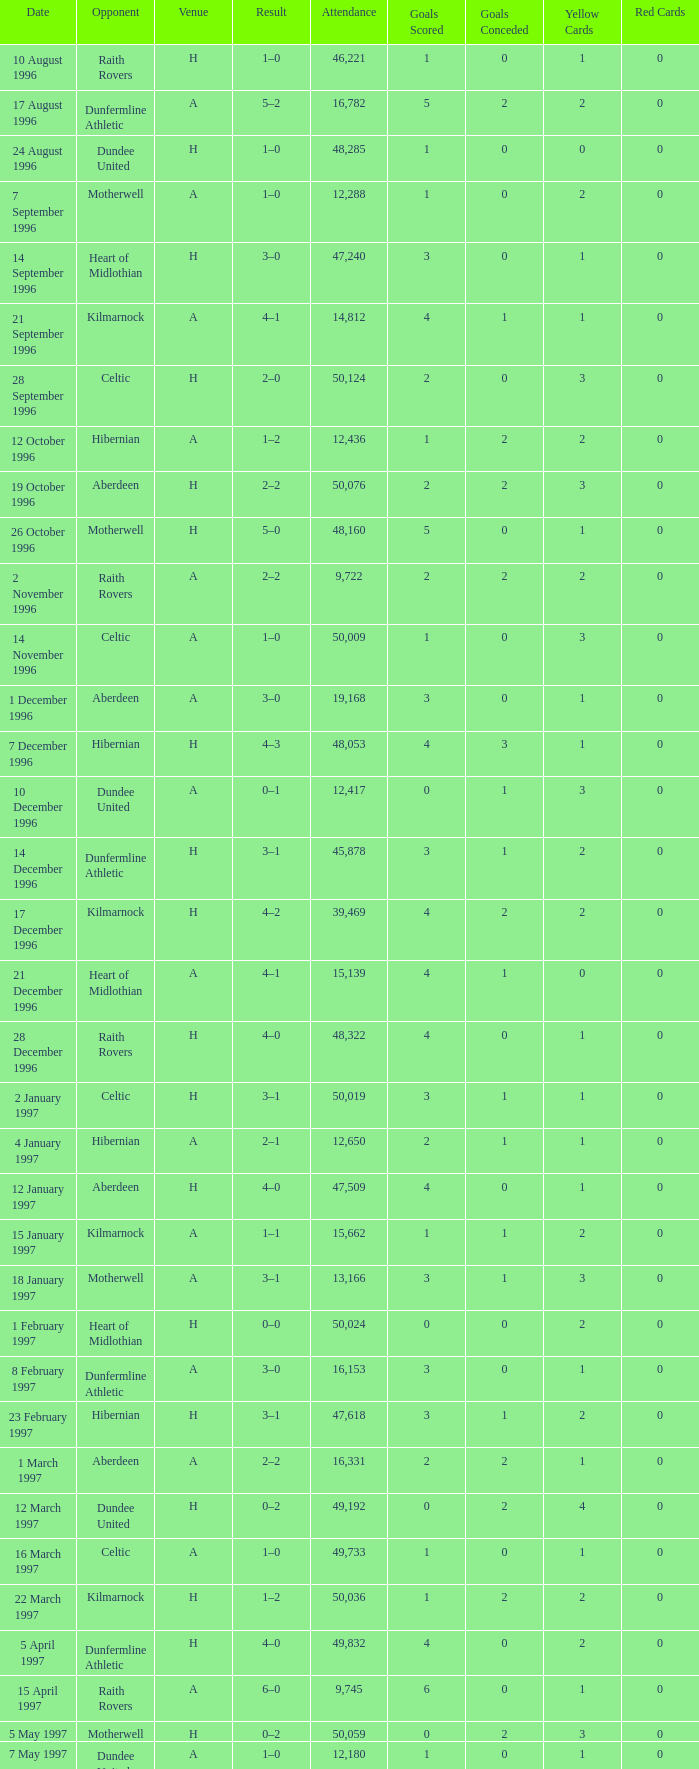Give me the full table as a dictionary. {'header': ['Date', 'Opponent', 'Venue', 'Result', 'Attendance', 'Goals Scored', 'Goals Conceded', 'Yellow Cards', 'Red Cards'], 'rows': [['10 August 1996', 'Raith Rovers', 'H', '1–0', '46,221', '1', '0', '1', '0'], ['17 August 1996', 'Dunfermline Athletic', 'A', '5–2', '16,782', '5', '2', '2', '0'], ['24 August 1996', 'Dundee United', 'H', '1–0', '48,285', '1', '0', '0', '0'], ['7 September 1996', 'Motherwell', 'A', '1–0', '12,288', '1', '0', '2', '0'], ['14 September 1996', 'Heart of Midlothian', 'H', '3–0', '47,240', '3', '0', '1', '0'], ['21 September 1996', 'Kilmarnock', 'A', '4–1', '14,812', '4', '1', '1', '0'], ['28 September 1996', 'Celtic', 'H', '2–0', '50,124', '2', '0', '3', '0'], ['12 October 1996', 'Hibernian', 'A', '1–2', '12,436', '1', '2', '2', '0'], ['19 October 1996', 'Aberdeen', 'H', '2–2', '50,076', '2', '2', '3', '0'], ['26 October 1996', 'Motherwell', 'H', '5–0', '48,160', '5', '0', '1', '0'], ['2 November 1996', 'Raith Rovers', 'A', '2–2', '9,722', '2', '2', '2', '0'], ['14 November 1996', 'Celtic', 'A', '1–0', '50,009', '1', '0', '3', '0'], ['1 December 1996', 'Aberdeen', 'A', '3–0', '19,168', '3', '0', '1', '0'], ['7 December 1996', 'Hibernian', 'H', '4–3', '48,053', '4', '3', '1', '0'], ['10 December 1996', 'Dundee United', 'A', '0–1', '12,417', '0', '1', '3', '0'], ['14 December 1996', 'Dunfermline Athletic', 'H', '3–1', '45,878', '3', '1', '2', '0'], ['17 December 1996', 'Kilmarnock', 'H', '4–2', '39,469', '4', '2', '2', '0'], ['21 December 1996', 'Heart of Midlothian', 'A', '4–1', '15,139', '4', '1', '0', '0'], ['28 December 1996', 'Raith Rovers', 'H', '4–0', '48,322', '4', '0', '1', '0'], ['2 January 1997', 'Celtic', 'H', '3–1', '50,019', '3', '1', '1', '0'], ['4 January 1997', 'Hibernian', 'A', '2–1', '12,650', '2', '1', '1', '0'], ['12 January 1997', 'Aberdeen', 'H', '4–0', '47,509', '4', '0', '1', '0'], ['15 January 1997', 'Kilmarnock', 'A', '1–1', '15,662', '1', '1', '2', '0'], ['18 January 1997', 'Motherwell', 'A', '3–1', '13,166', '3', '1', '3', '0'], ['1 February 1997', 'Heart of Midlothian', 'H', '0–0', '50,024', '0', '0', '2', '0'], ['8 February 1997', 'Dunfermline Athletic', 'A', '3–0', '16,153', '3', '0', '1', '0'], ['23 February 1997', 'Hibernian', 'H', '3–1', '47,618', '3', '1', '2', '0'], ['1 March 1997', 'Aberdeen', 'A', '2–2', '16,331', '2', '2', '1', '0'], ['12 March 1997', 'Dundee United', 'H', '0–2', '49,192', '0', '2', '4', '0'], ['16 March 1997', 'Celtic', 'A', '1–0', '49,733', '1', '0', '1', '0'], ['22 March 1997', 'Kilmarnock', 'H', '1–2', '50,036', '1', '2', '2', '0'], ['5 April 1997', 'Dunfermline Athletic', 'H', '4–0', '49,832', '4', '0', '2', '0'], ['15 April 1997', 'Raith Rovers', 'A', '6–0', '9,745', '6', '0', '1', '0'], ['5 May 1997', 'Motherwell', 'H', '0–2', '50,059', '0', '2', '3', '0'], ['7 May 1997', 'Dundee United', 'A', '1–0', '12,180', '1', '0', '1', '0'], ['10 May 1997', 'Heart of Midlothian', 'A', '1–3', '13,097', '1', '3', '2', '0']]} When did venue A have an attendance larger than 48,053, and a result of 1–0? 14 November 1996, 16 March 1997. 